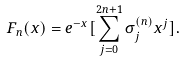Convert formula to latex. <formula><loc_0><loc_0><loc_500><loc_500>F _ { n } ( x ) = e ^ { - x } [ \sum _ { j = 0 } ^ { 2 n + 1 } \sigma _ { j } ^ { ( n ) } x ^ { j } ] .</formula> 